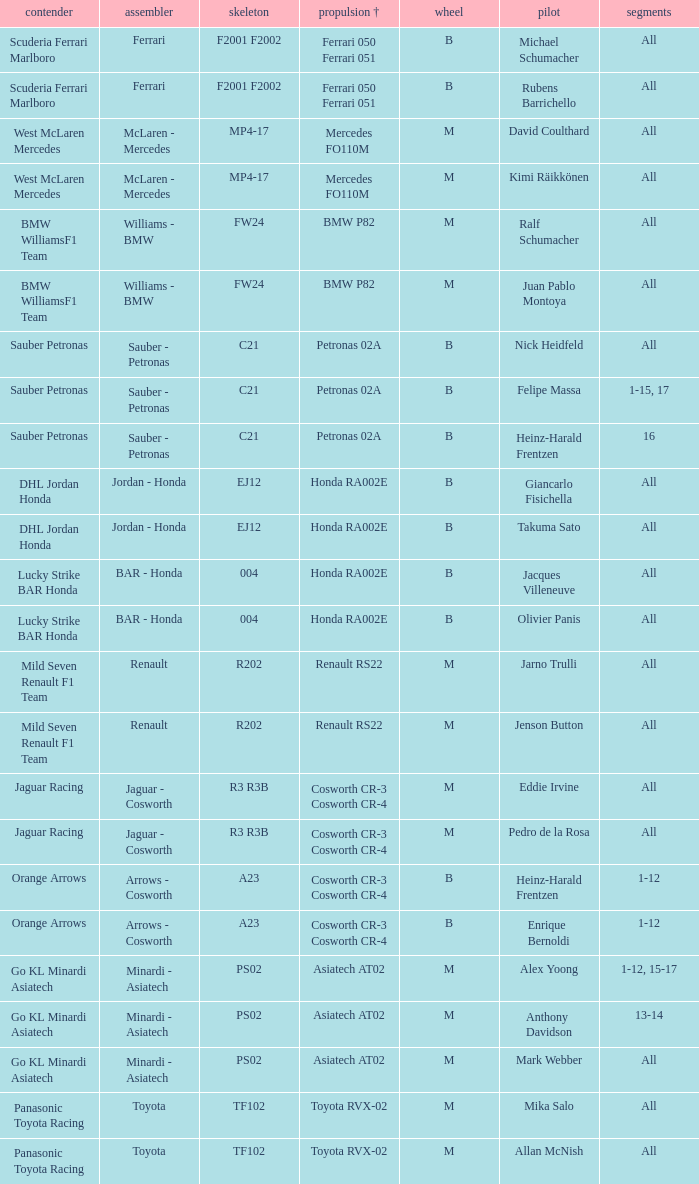What is the chassis when the tyre is b, the engine is ferrari 050 ferrari 051 and the driver is rubens barrichello? F2001 F2002. 